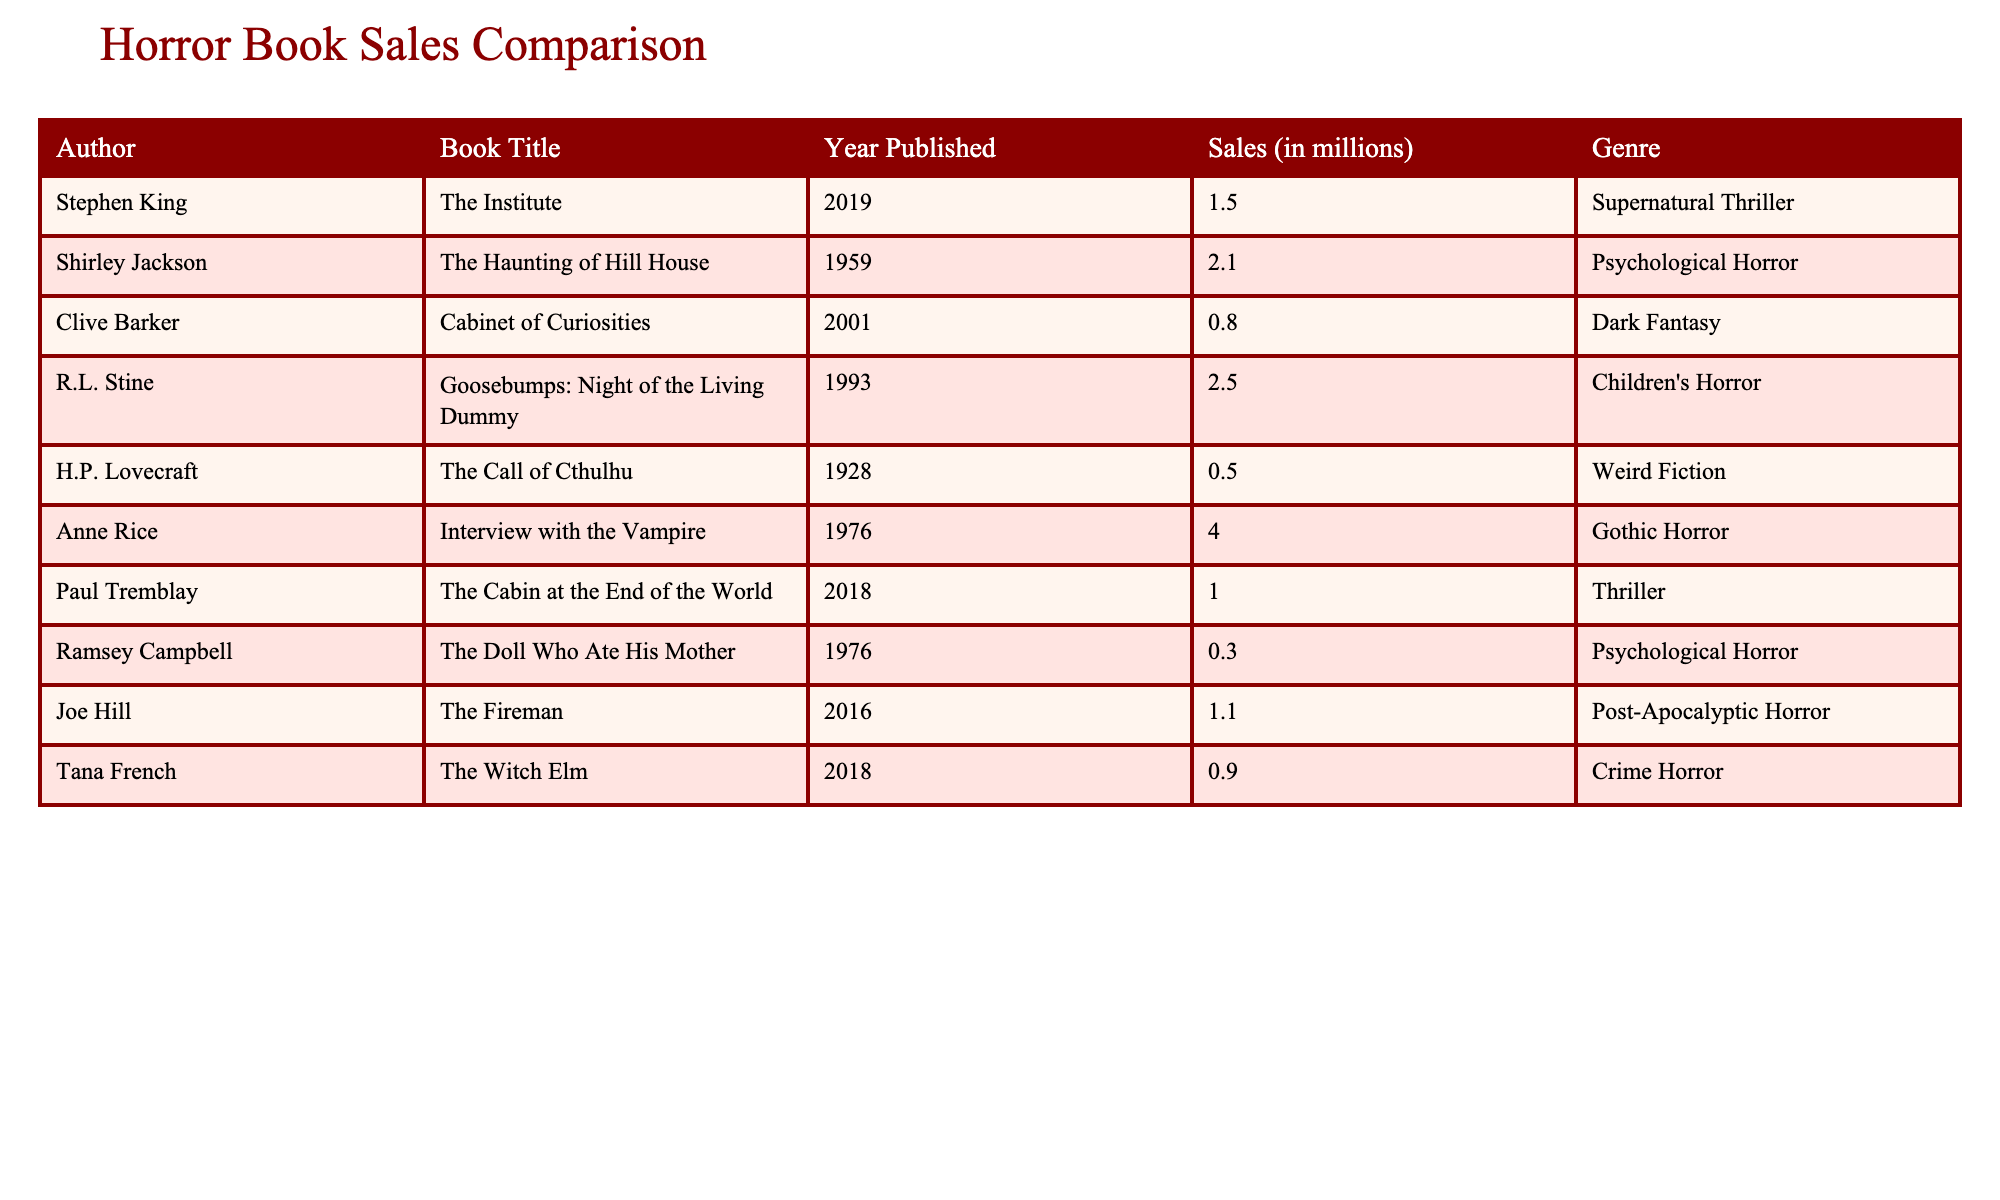What is the title of the horror book by Anne Rice? The table lists Anne Rice and shows that her book title is "Interview with the Vampire."
Answer: Interview with the Vampire Which author has the highest book sales, and what are those sales figures? Anne Rice's book has the highest sales at 4.0 million copies.
Answer: Anne Rice, 4.0 million What is the total sales of the books written by R.L. Stine and Shirley Jackson? R.L. Stine's sales are 2.5 million and Shirley Jackson's are 2.1 million. Adding them gives 2.5 + 2.1 = 4.6 million.
Answer: 4.6 million Is "Cabinet of Curiosities" by Clive Barker a bestseller based on sales figures? "Cabinet of Curiosities" has sales of 0.8 million, which does not categorize it as a bestseller.
Answer: No How many authors have books with sales figures below 1 million? The books by Clive Barker (0.8 million), H.P. Lovecraft (0.5 million), and Ramsey Campbell (0.3 million) fall below 1 million, totaling three authors.
Answer: 3 What is the average sales figure for the authors featured in the table? To find the average, sum all the sales (1.5 + 2.1 + 0.8 + 2.5 + 0.5 + 4.0 + 1.0 + 0.3 + 1.1 + 0.9 = 13.4 million) and divide by the number of authors (10). Thus, 13.4 / 10 = 1.34 million.
Answer: 1.34 million Which genre has the book with the lowest sales, and what is that figure? The book "The Doll Who Ate His Mother" by Ramsey Campbell is in the Psychological Horror genre and has the lowest sales of 0.3 million.
Answer: Psychological Horror, 0.3 million What year was "The Institute" by Stephen King published? According to the table, "The Institute" was published in 2019.
Answer: 2019 Are there any books published before 1960 that have more than 2 million copies sold? The only book before 1960 with sales above 2 million is "The Haunting of Hill House" by Shirley Jackson, which has sales of 2.1 million. Thus, the answer is yes.
Answer: Yes 